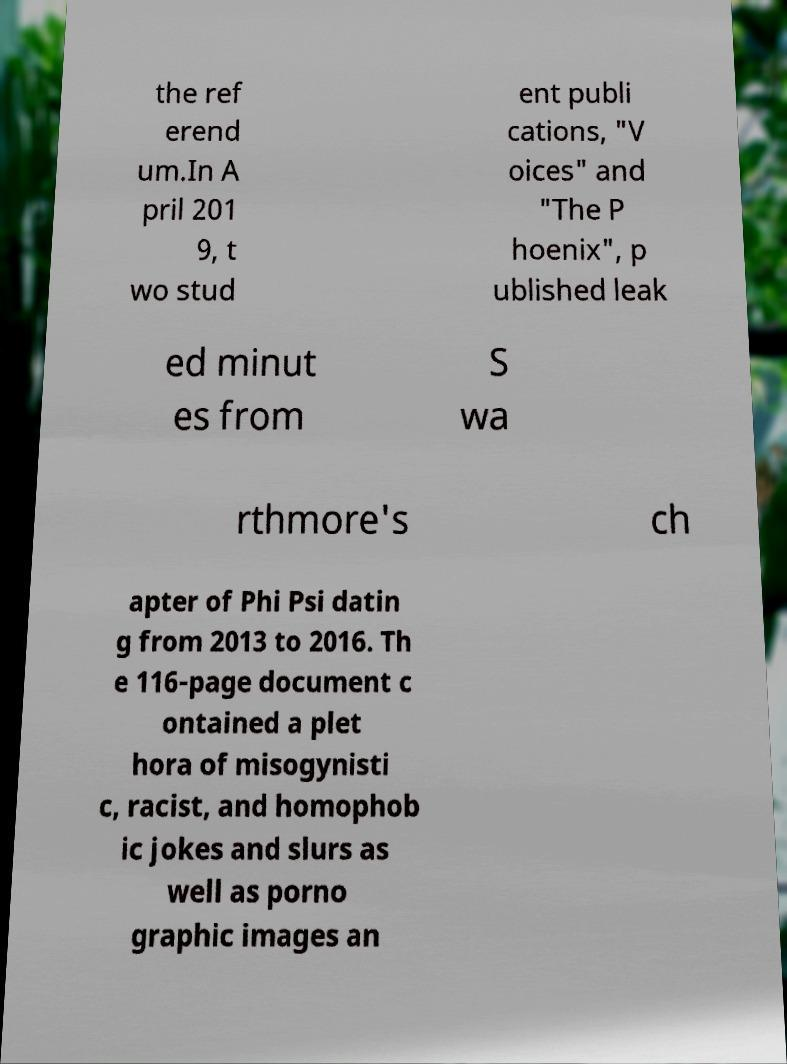Could you assist in decoding the text presented in this image and type it out clearly? the ref erend um.In A pril 201 9, t wo stud ent publi cations, "V oices" and "The P hoenix", p ublished leak ed minut es from S wa rthmore's ch apter of Phi Psi datin g from 2013 to 2016. Th e 116-page document c ontained a plet hora of misogynisti c, racist, and homophob ic jokes and slurs as well as porno graphic images an 